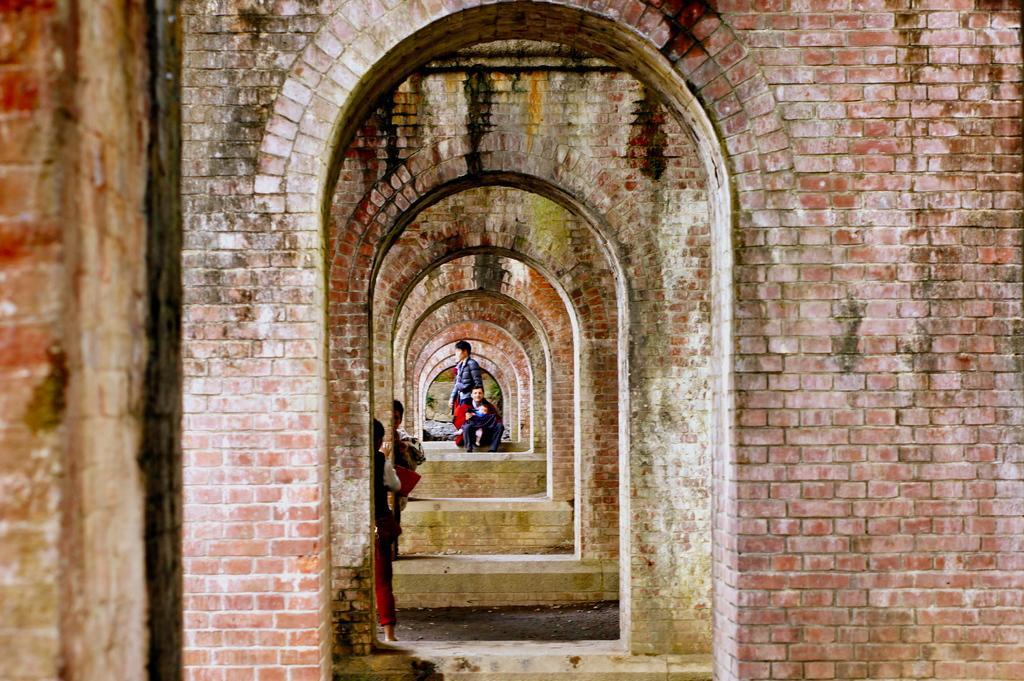Please provide a concise description of this image. In this image we can see an architecture with many walls and the arches and we can see the group of people and many other items. 